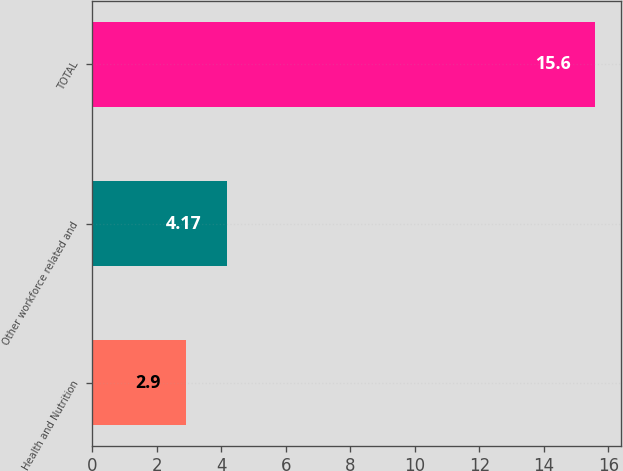<chart> <loc_0><loc_0><loc_500><loc_500><bar_chart><fcel>Health and Nutrition<fcel>Other workforce related and<fcel>TOTAL<nl><fcel>2.9<fcel>4.17<fcel>15.6<nl></chart> 